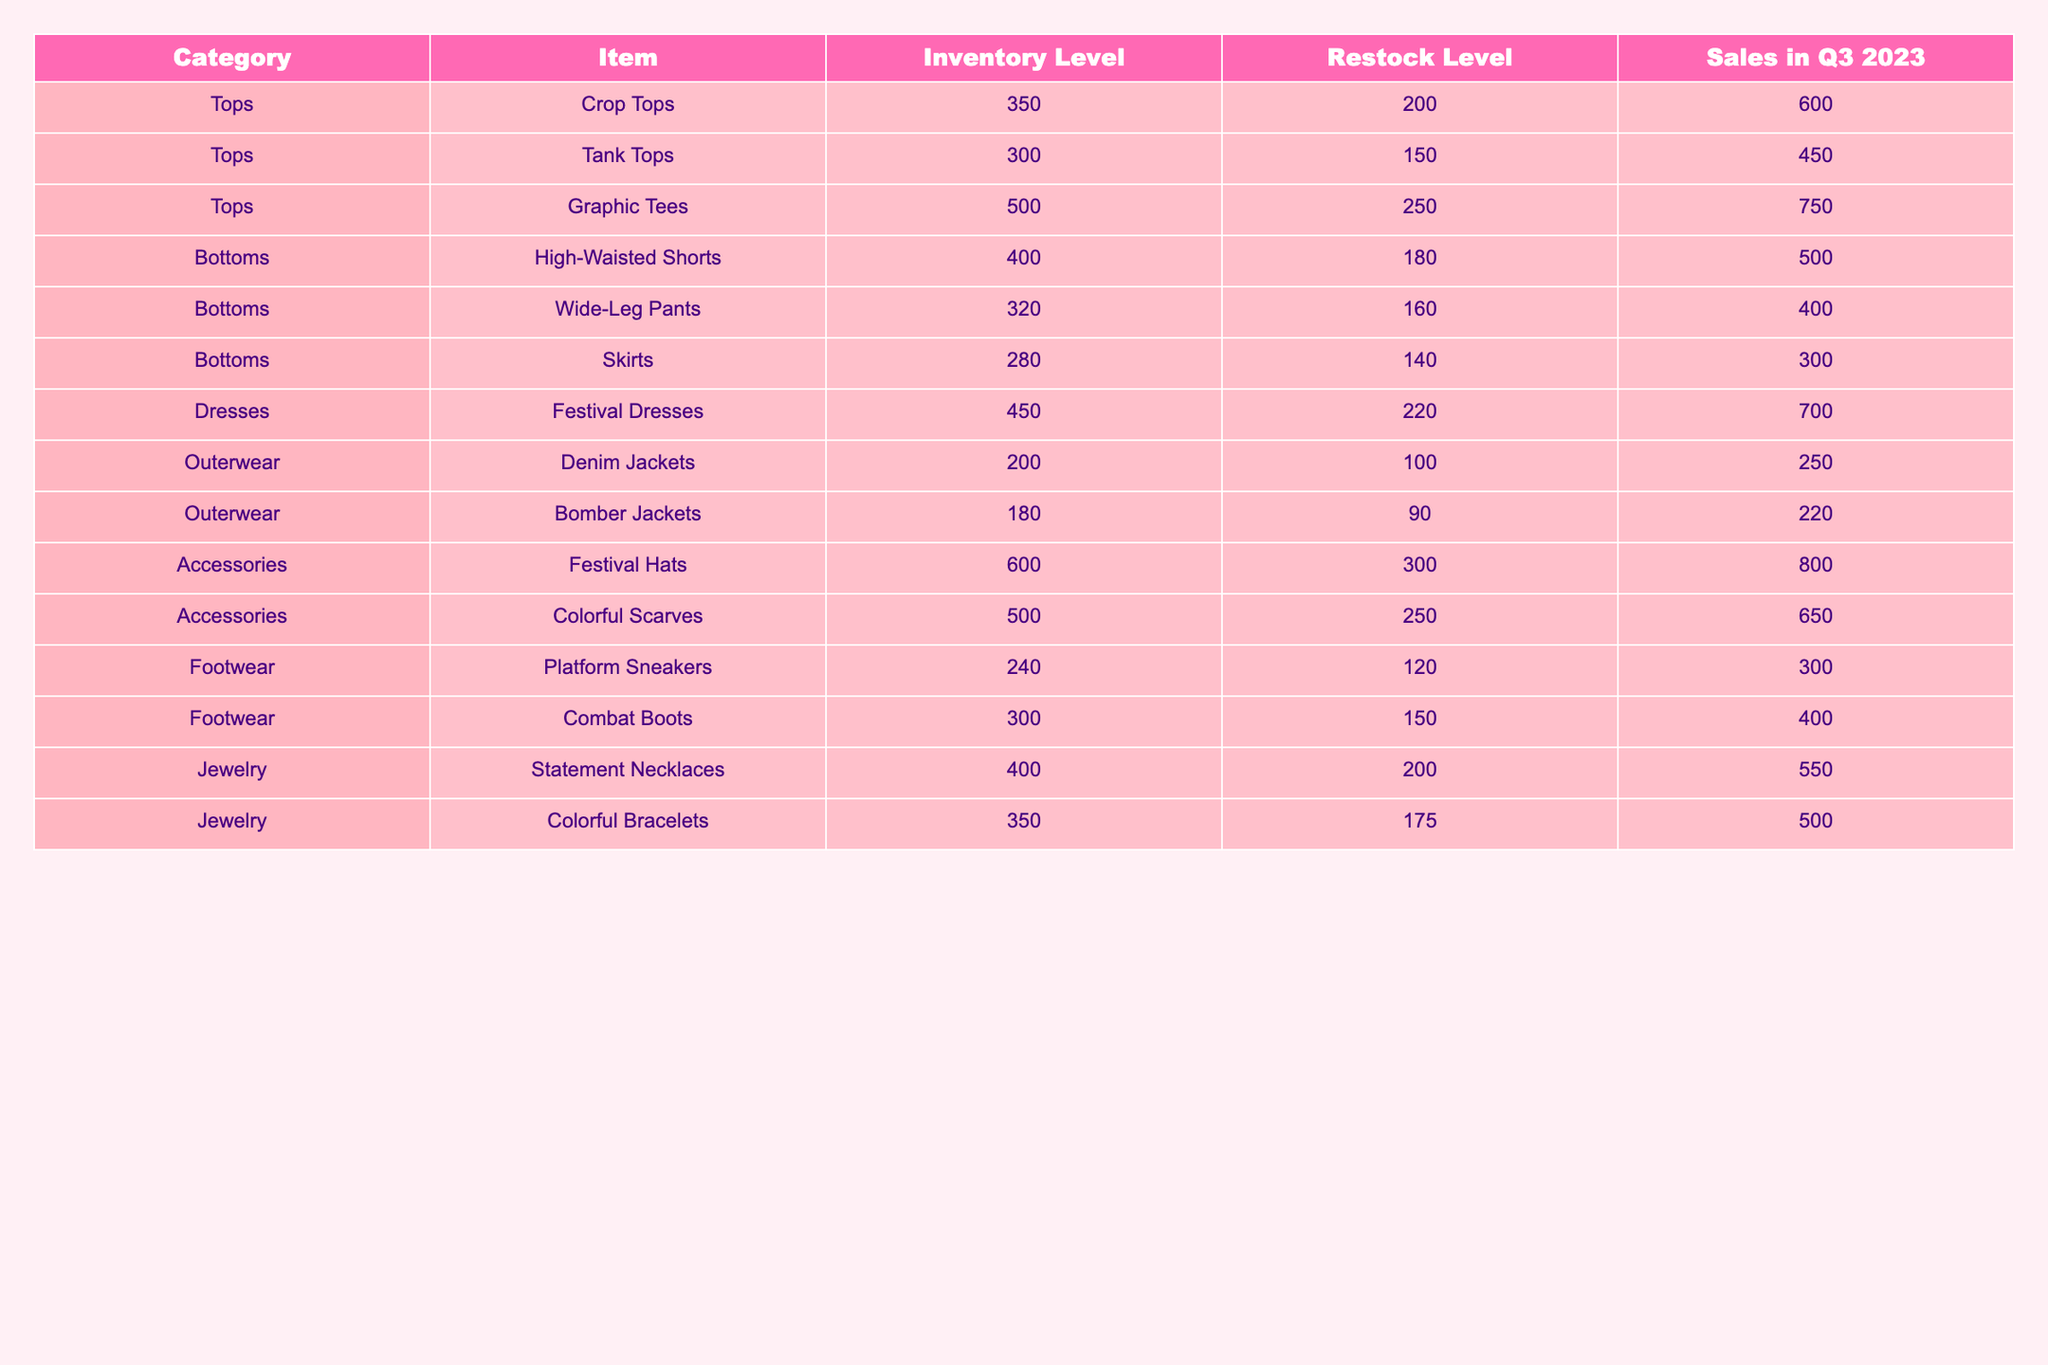What is the inventory level of Festival Dresses? The table shows that the inventory level for Festival Dresses is listed under the Dresses category. The corresponding value is 450.
Answer: 450 What is the restock level for Graphic Tees? The restock level for Graphic Tees, found in the Tops category, is stated as 250.
Answer: 250 How many more Festival Hats are available than Tank Tops? The inventory for Festival Hats is 600, and for Tank Tops, it is 300. The difference is calculated as 600 - 300 = 300.
Answer: 300 What is the total inventory level for all the Bottoms items? The total inventory for Bottoms includes High-Waisted Shorts (400), Wide-Leg Pants (320), and Skirts (280). Summing these values gives 400 + 320 + 280 = 1000.
Answer: 1000 Which item has the highest sales in Q3 2023? By examining the Sales in Q3 column, we find that Festival Hats have the highest sales at 800, compared to other items.
Answer: Festival Hats Are there more Statement Necklaces or Colorful Scarves in inventory? Statement Necklaces have an inventory level of 400, while Colorful Scarves have 500. Since 500 > 400, there are more Colorful Scarves.
Answer: Yes, more Colorful Scarves What is the average inventory level of all the accessories combined? The accessories are Festival Hats (600) and Colorful Scarves (500). The average is calculated as (600 + 500) / 2 = 550.
Answer: 550 If we restock the Bottoms items to their restock levels, what will their new total inventory be? Current inventory levels for Bottoms are High-Waisted Shorts (400), Wide-Leg Pants (320), and Skirts (280), totaling 1000. The restock levels are 180, 160, and 140 respectively. After restocking, the new totals will be 180 + 160 + 140 = 480. Subtracting from the original, new total will be 1000 + (480 - 1000) = 480. This indicates the total will be 480 after restock.
Answer: 480 Which category overall has the highest sales in Q3 2023? If we sum up the sales for each category: Tops (600 + 450 + 750 = 1800), Bottoms (500 + 400 + 300 = 1200), Dresses (700 = 700), Outerwear (250 + 220 = 470), Accessories (800 + 650 = 1450), Footwear (300 + 400 = 700), Jewelry (550 + 500 = 1050). The highest category is Tops with 1800.
Answer: Tops How would restocking each category item affect the total inventory levels? Inventory levels under each category are summed and compared to the restock levels. For instance, with Tops current inventory of 500 at restock level 200, the increase means effective management is needed. Grouping and totaling each category would show the overall net change. Final summation needs to compare above average restock impacts.
Answer: Varies by category 